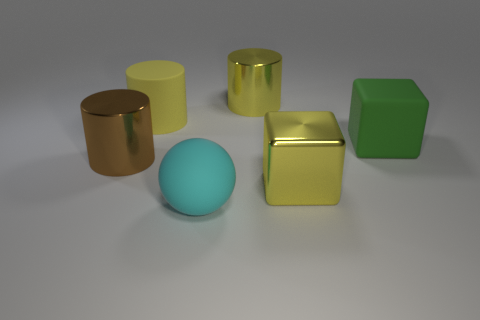What material do the golden objects seem to be? The golden objects in the image have a reflective surface that gives them a metallic appearance, suggesting they could be made of a material similar to polished brass or gold. 